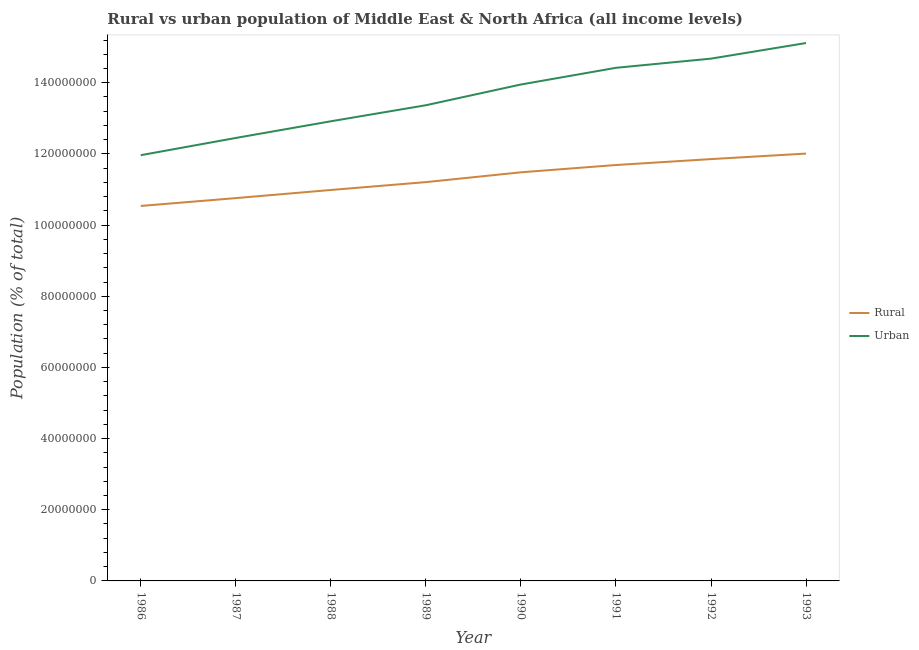Does the line corresponding to rural population density intersect with the line corresponding to urban population density?
Your answer should be compact. No. What is the rural population density in 1990?
Your answer should be compact. 1.15e+08. Across all years, what is the maximum urban population density?
Make the answer very short. 1.51e+08. Across all years, what is the minimum urban population density?
Your answer should be very brief. 1.20e+08. In which year was the urban population density maximum?
Provide a succinct answer. 1993. What is the total rural population density in the graph?
Your answer should be very brief. 9.05e+08. What is the difference between the urban population density in 1987 and that in 1988?
Ensure brevity in your answer.  -4.68e+06. What is the difference between the urban population density in 1988 and the rural population density in 1990?
Offer a very short reply. 1.43e+07. What is the average urban population density per year?
Your answer should be compact. 1.36e+08. In the year 1986, what is the difference between the urban population density and rural population density?
Your answer should be compact. 1.43e+07. What is the ratio of the urban population density in 1988 to that in 1989?
Keep it short and to the point. 0.97. What is the difference between the highest and the second highest urban population density?
Keep it short and to the point. 4.39e+06. What is the difference between the highest and the lowest urban population density?
Your answer should be compact. 3.15e+07. In how many years, is the rural population density greater than the average rural population density taken over all years?
Offer a very short reply. 4. Is the sum of the urban population density in 1991 and 1993 greater than the maximum rural population density across all years?
Your answer should be compact. Yes. Does the urban population density monotonically increase over the years?
Make the answer very short. Yes. How many lines are there?
Provide a short and direct response. 2. How many years are there in the graph?
Make the answer very short. 8. Are the values on the major ticks of Y-axis written in scientific E-notation?
Make the answer very short. No. Does the graph contain any zero values?
Keep it short and to the point. No. Does the graph contain grids?
Provide a succinct answer. No. How are the legend labels stacked?
Offer a very short reply. Vertical. What is the title of the graph?
Your answer should be very brief. Rural vs urban population of Middle East & North Africa (all income levels). What is the label or title of the Y-axis?
Your response must be concise. Population (% of total). What is the Population (% of total) of Rural in 1986?
Give a very brief answer. 1.05e+08. What is the Population (% of total) in Urban in 1986?
Your response must be concise. 1.20e+08. What is the Population (% of total) in Rural in 1987?
Ensure brevity in your answer.  1.08e+08. What is the Population (% of total) in Urban in 1987?
Make the answer very short. 1.24e+08. What is the Population (% of total) of Rural in 1988?
Offer a very short reply. 1.10e+08. What is the Population (% of total) of Urban in 1988?
Your answer should be very brief. 1.29e+08. What is the Population (% of total) of Rural in 1989?
Keep it short and to the point. 1.12e+08. What is the Population (% of total) in Urban in 1989?
Make the answer very short. 1.34e+08. What is the Population (% of total) of Rural in 1990?
Offer a very short reply. 1.15e+08. What is the Population (% of total) of Urban in 1990?
Provide a succinct answer. 1.40e+08. What is the Population (% of total) in Rural in 1991?
Keep it short and to the point. 1.17e+08. What is the Population (% of total) in Urban in 1991?
Give a very brief answer. 1.44e+08. What is the Population (% of total) of Rural in 1992?
Provide a short and direct response. 1.19e+08. What is the Population (% of total) of Urban in 1992?
Keep it short and to the point. 1.47e+08. What is the Population (% of total) of Rural in 1993?
Give a very brief answer. 1.20e+08. What is the Population (% of total) of Urban in 1993?
Your response must be concise. 1.51e+08. Across all years, what is the maximum Population (% of total) in Rural?
Provide a succinct answer. 1.20e+08. Across all years, what is the maximum Population (% of total) in Urban?
Give a very brief answer. 1.51e+08. Across all years, what is the minimum Population (% of total) of Rural?
Make the answer very short. 1.05e+08. Across all years, what is the minimum Population (% of total) in Urban?
Give a very brief answer. 1.20e+08. What is the total Population (% of total) of Rural in the graph?
Ensure brevity in your answer.  9.05e+08. What is the total Population (% of total) of Urban in the graph?
Your answer should be compact. 1.09e+09. What is the difference between the Population (% of total) in Rural in 1986 and that in 1987?
Offer a terse response. -2.20e+06. What is the difference between the Population (% of total) of Urban in 1986 and that in 1987?
Offer a very short reply. -4.84e+06. What is the difference between the Population (% of total) of Rural in 1986 and that in 1988?
Your answer should be very brief. -4.49e+06. What is the difference between the Population (% of total) of Urban in 1986 and that in 1988?
Ensure brevity in your answer.  -9.53e+06. What is the difference between the Population (% of total) in Rural in 1986 and that in 1989?
Make the answer very short. -6.70e+06. What is the difference between the Population (% of total) of Urban in 1986 and that in 1989?
Offer a terse response. -1.40e+07. What is the difference between the Population (% of total) in Rural in 1986 and that in 1990?
Your answer should be compact. -9.45e+06. What is the difference between the Population (% of total) in Urban in 1986 and that in 1990?
Offer a terse response. -1.99e+07. What is the difference between the Population (% of total) in Rural in 1986 and that in 1991?
Your answer should be compact. -1.15e+07. What is the difference between the Population (% of total) of Urban in 1986 and that in 1991?
Make the answer very short. -2.46e+07. What is the difference between the Population (% of total) in Rural in 1986 and that in 1992?
Offer a very short reply. -1.32e+07. What is the difference between the Population (% of total) of Urban in 1986 and that in 1992?
Provide a short and direct response. -2.71e+07. What is the difference between the Population (% of total) in Rural in 1986 and that in 1993?
Keep it short and to the point. -1.47e+07. What is the difference between the Population (% of total) of Urban in 1986 and that in 1993?
Provide a succinct answer. -3.15e+07. What is the difference between the Population (% of total) of Rural in 1987 and that in 1988?
Your response must be concise. -2.29e+06. What is the difference between the Population (% of total) of Urban in 1987 and that in 1988?
Ensure brevity in your answer.  -4.68e+06. What is the difference between the Population (% of total) in Rural in 1987 and that in 1989?
Your answer should be very brief. -4.50e+06. What is the difference between the Population (% of total) of Urban in 1987 and that in 1989?
Your answer should be compact. -9.20e+06. What is the difference between the Population (% of total) in Rural in 1987 and that in 1990?
Offer a very short reply. -7.25e+06. What is the difference between the Population (% of total) of Urban in 1987 and that in 1990?
Offer a terse response. -1.50e+07. What is the difference between the Population (% of total) in Rural in 1987 and that in 1991?
Make the answer very short. -9.30e+06. What is the difference between the Population (% of total) in Urban in 1987 and that in 1991?
Make the answer very short. -1.97e+07. What is the difference between the Population (% of total) in Rural in 1987 and that in 1992?
Offer a terse response. -1.10e+07. What is the difference between the Population (% of total) in Urban in 1987 and that in 1992?
Give a very brief answer. -2.23e+07. What is the difference between the Population (% of total) of Rural in 1987 and that in 1993?
Provide a short and direct response. -1.25e+07. What is the difference between the Population (% of total) of Urban in 1987 and that in 1993?
Provide a succinct answer. -2.67e+07. What is the difference between the Population (% of total) in Rural in 1988 and that in 1989?
Ensure brevity in your answer.  -2.21e+06. What is the difference between the Population (% of total) of Urban in 1988 and that in 1989?
Offer a terse response. -4.51e+06. What is the difference between the Population (% of total) in Rural in 1988 and that in 1990?
Ensure brevity in your answer.  -4.97e+06. What is the difference between the Population (% of total) of Urban in 1988 and that in 1990?
Your response must be concise. -1.03e+07. What is the difference between the Population (% of total) of Rural in 1988 and that in 1991?
Offer a terse response. -7.02e+06. What is the difference between the Population (% of total) of Urban in 1988 and that in 1991?
Make the answer very short. -1.50e+07. What is the difference between the Population (% of total) in Rural in 1988 and that in 1992?
Offer a very short reply. -8.68e+06. What is the difference between the Population (% of total) in Urban in 1988 and that in 1992?
Give a very brief answer. -1.76e+07. What is the difference between the Population (% of total) of Rural in 1988 and that in 1993?
Keep it short and to the point. -1.02e+07. What is the difference between the Population (% of total) of Urban in 1988 and that in 1993?
Keep it short and to the point. -2.20e+07. What is the difference between the Population (% of total) in Rural in 1989 and that in 1990?
Your response must be concise. -2.76e+06. What is the difference between the Population (% of total) in Urban in 1989 and that in 1990?
Provide a short and direct response. -5.83e+06. What is the difference between the Population (% of total) of Rural in 1989 and that in 1991?
Your answer should be compact. -4.81e+06. What is the difference between the Population (% of total) in Urban in 1989 and that in 1991?
Make the answer very short. -1.05e+07. What is the difference between the Population (% of total) in Rural in 1989 and that in 1992?
Offer a terse response. -6.47e+06. What is the difference between the Population (% of total) of Urban in 1989 and that in 1992?
Make the answer very short. -1.31e+07. What is the difference between the Population (% of total) in Rural in 1989 and that in 1993?
Your answer should be compact. -8.02e+06. What is the difference between the Population (% of total) of Urban in 1989 and that in 1993?
Provide a succinct answer. -1.75e+07. What is the difference between the Population (% of total) in Rural in 1990 and that in 1991?
Offer a terse response. -2.05e+06. What is the difference between the Population (% of total) in Urban in 1990 and that in 1991?
Your response must be concise. -4.69e+06. What is the difference between the Population (% of total) of Rural in 1990 and that in 1992?
Keep it short and to the point. -3.71e+06. What is the difference between the Population (% of total) of Urban in 1990 and that in 1992?
Your answer should be compact. -7.27e+06. What is the difference between the Population (% of total) in Rural in 1990 and that in 1993?
Give a very brief answer. -5.26e+06. What is the difference between the Population (% of total) of Urban in 1990 and that in 1993?
Provide a succinct answer. -1.17e+07. What is the difference between the Population (% of total) of Rural in 1991 and that in 1992?
Your answer should be compact. -1.66e+06. What is the difference between the Population (% of total) in Urban in 1991 and that in 1992?
Keep it short and to the point. -2.58e+06. What is the difference between the Population (% of total) of Rural in 1991 and that in 1993?
Provide a short and direct response. -3.21e+06. What is the difference between the Population (% of total) of Urban in 1991 and that in 1993?
Make the answer very short. -6.97e+06. What is the difference between the Population (% of total) in Rural in 1992 and that in 1993?
Make the answer very short. -1.55e+06. What is the difference between the Population (% of total) in Urban in 1992 and that in 1993?
Offer a terse response. -4.39e+06. What is the difference between the Population (% of total) of Rural in 1986 and the Population (% of total) of Urban in 1987?
Your answer should be compact. -1.91e+07. What is the difference between the Population (% of total) in Rural in 1986 and the Population (% of total) in Urban in 1988?
Give a very brief answer. -2.38e+07. What is the difference between the Population (% of total) in Rural in 1986 and the Population (% of total) in Urban in 1989?
Your answer should be very brief. -2.83e+07. What is the difference between the Population (% of total) in Rural in 1986 and the Population (% of total) in Urban in 1990?
Offer a very short reply. -3.41e+07. What is the difference between the Population (% of total) in Rural in 1986 and the Population (% of total) in Urban in 1991?
Provide a short and direct response. -3.88e+07. What is the difference between the Population (% of total) in Rural in 1986 and the Population (% of total) in Urban in 1992?
Offer a terse response. -4.14e+07. What is the difference between the Population (% of total) in Rural in 1986 and the Population (% of total) in Urban in 1993?
Offer a terse response. -4.58e+07. What is the difference between the Population (% of total) of Rural in 1987 and the Population (% of total) of Urban in 1988?
Give a very brief answer. -2.16e+07. What is the difference between the Population (% of total) of Rural in 1987 and the Population (% of total) of Urban in 1989?
Keep it short and to the point. -2.61e+07. What is the difference between the Population (% of total) in Rural in 1987 and the Population (% of total) in Urban in 1990?
Keep it short and to the point. -3.19e+07. What is the difference between the Population (% of total) in Rural in 1987 and the Population (% of total) in Urban in 1991?
Give a very brief answer. -3.66e+07. What is the difference between the Population (% of total) of Rural in 1987 and the Population (% of total) of Urban in 1992?
Give a very brief answer. -3.92e+07. What is the difference between the Population (% of total) of Rural in 1987 and the Population (% of total) of Urban in 1993?
Offer a terse response. -4.36e+07. What is the difference between the Population (% of total) of Rural in 1988 and the Population (% of total) of Urban in 1989?
Your response must be concise. -2.38e+07. What is the difference between the Population (% of total) in Rural in 1988 and the Population (% of total) in Urban in 1990?
Ensure brevity in your answer.  -2.96e+07. What is the difference between the Population (% of total) in Rural in 1988 and the Population (% of total) in Urban in 1991?
Offer a very short reply. -3.43e+07. What is the difference between the Population (% of total) in Rural in 1988 and the Population (% of total) in Urban in 1992?
Provide a short and direct response. -3.69e+07. What is the difference between the Population (% of total) in Rural in 1988 and the Population (% of total) in Urban in 1993?
Offer a very short reply. -4.13e+07. What is the difference between the Population (% of total) of Rural in 1989 and the Population (% of total) of Urban in 1990?
Keep it short and to the point. -2.74e+07. What is the difference between the Population (% of total) of Rural in 1989 and the Population (% of total) of Urban in 1991?
Your response must be concise. -3.21e+07. What is the difference between the Population (% of total) of Rural in 1989 and the Population (% of total) of Urban in 1992?
Offer a very short reply. -3.47e+07. What is the difference between the Population (% of total) of Rural in 1989 and the Population (% of total) of Urban in 1993?
Ensure brevity in your answer.  -3.91e+07. What is the difference between the Population (% of total) in Rural in 1990 and the Population (% of total) in Urban in 1991?
Provide a succinct answer. -2.94e+07. What is the difference between the Population (% of total) of Rural in 1990 and the Population (% of total) of Urban in 1992?
Your answer should be compact. -3.19e+07. What is the difference between the Population (% of total) in Rural in 1990 and the Population (% of total) in Urban in 1993?
Give a very brief answer. -3.63e+07. What is the difference between the Population (% of total) in Rural in 1991 and the Population (% of total) in Urban in 1992?
Your answer should be compact. -2.99e+07. What is the difference between the Population (% of total) in Rural in 1991 and the Population (% of total) in Urban in 1993?
Your answer should be very brief. -3.43e+07. What is the difference between the Population (% of total) in Rural in 1992 and the Population (% of total) in Urban in 1993?
Give a very brief answer. -3.26e+07. What is the average Population (% of total) in Rural per year?
Your answer should be compact. 1.13e+08. What is the average Population (% of total) in Urban per year?
Ensure brevity in your answer.  1.36e+08. In the year 1986, what is the difference between the Population (% of total) in Rural and Population (% of total) in Urban?
Keep it short and to the point. -1.43e+07. In the year 1987, what is the difference between the Population (% of total) of Rural and Population (% of total) of Urban?
Make the answer very short. -1.69e+07. In the year 1988, what is the difference between the Population (% of total) of Rural and Population (% of total) of Urban?
Your answer should be compact. -1.93e+07. In the year 1989, what is the difference between the Population (% of total) of Rural and Population (% of total) of Urban?
Make the answer very short. -2.16e+07. In the year 1990, what is the difference between the Population (% of total) of Rural and Population (% of total) of Urban?
Give a very brief answer. -2.47e+07. In the year 1991, what is the difference between the Population (% of total) of Rural and Population (% of total) of Urban?
Your answer should be compact. -2.73e+07. In the year 1992, what is the difference between the Population (% of total) in Rural and Population (% of total) in Urban?
Make the answer very short. -2.82e+07. In the year 1993, what is the difference between the Population (% of total) in Rural and Population (% of total) in Urban?
Ensure brevity in your answer.  -3.11e+07. What is the ratio of the Population (% of total) of Rural in 1986 to that in 1987?
Keep it short and to the point. 0.98. What is the ratio of the Population (% of total) in Urban in 1986 to that in 1987?
Your response must be concise. 0.96. What is the ratio of the Population (% of total) of Rural in 1986 to that in 1988?
Your answer should be very brief. 0.96. What is the ratio of the Population (% of total) in Urban in 1986 to that in 1988?
Ensure brevity in your answer.  0.93. What is the ratio of the Population (% of total) of Rural in 1986 to that in 1989?
Ensure brevity in your answer.  0.94. What is the ratio of the Population (% of total) of Urban in 1986 to that in 1989?
Your answer should be very brief. 0.9. What is the ratio of the Population (% of total) in Rural in 1986 to that in 1990?
Your answer should be very brief. 0.92. What is the ratio of the Population (% of total) of Urban in 1986 to that in 1990?
Offer a terse response. 0.86. What is the ratio of the Population (% of total) in Rural in 1986 to that in 1991?
Offer a very short reply. 0.9. What is the ratio of the Population (% of total) of Urban in 1986 to that in 1991?
Keep it short and to the point. 0.83. What is the ratio of the Population (% of total) of Rural in 1986 to that in 1992?
Ensure brevity in your answer.  0.89. What is the ratio of the Population (% of total) of Urban in 1986 to that in 1992?
Offer a very short reply. 0.82. What is the ratio of the Population (% of total) in Rural in 1986 to that in 1993?
Make the answer very short. 0.88. What is the ratio of the Population (% of total) of Urban in 1986 to that in 1993?
Ensure brevity in your answer.  0.79. What is the ratio of the Population (% of total) in Rural in 1987 to that in 1988?
Ensure brevity in your answer.  0.98. What is the ratio of the Population (% of total) in Urban in 1987 to that in 1988?
Your response must be concise. 0.96. What is the ratio of the Population (% of total) of Rural in 1987 to that in 1989?
Give a very brief answer. 0.96. What is the ratio of the Population (% of total) of Urban in 1987 to that in 1989?
Ensure brevity in your answer.  0.93. What is the ratio of the Population (% of total) of Rural in 1987 to that in 1990?
Keep it short and to the point. 0.94. What is the ratio of the Population (% of total) of Urban in 1987 to that in 1990?
Give a very brief answer. 0.89. What is the ratio of the Population (% of total) in Rural in 1987 to that in 1991?
Your response must be concise. 0.92. What is the ratio of the Population (% of total) in Urban in 1987 to that in 1991?
Give a very brief answer. 0.86. What is the ratio of the Population (% of total) of Rural in 1987 to that in 1992?
Your answer should be very brief. 0.91. What is the ratio of the Population (% of total) in Urban in 1987 to that in 1992?
Provide a succinct answer. 0.85. What is the ratio of the Population (% of total) of Rural in 1987 to that in 1993?
Give a very brief answer. 0.9. What is the ratio of the Population (% of total) of Urban in 1987 to that in 1993?
Your answer should be very brief. 0.82. What is the ratio of the Population (% of total) in Rural in 1988 to that in 1989?
Offer a very short reply. 0.98. What is the ratio of the Population (% of total) of Urban in 1988 to that in 1989?
Provide a short and direct response. 0.97. What is the ratio of the Population (% of total) in Rural in 1988 to that in 1990?
Give a very brief answer. 0.96. What is the ratio of the Population (% of total) in Urban in 1988 to that in 1990?
Offer a terse response. 0.93. What is the ratio of the Population (% of total) in Urban in 1988 to that in 1991?
Provide a succinct answer. 0.9. What is the ratio of the Population (% of total) in Rural in 1988 to that in 1992?
Give a very brief answer. 0.93. What is the ratio of the Population (% of total) in Rural in 1988 to that in 1993?
Your answer should be compact. 0.91. What is the ratio of the Population (% of total) of Urban in 1988 to that in 1993?
Provide a succinct answer. 0.85. What is the ratio of the Population (% of total) of Rural in 1989 to that in 1990?
Give a very brief answer. 0.98. What is the ratio of the Population (% of total) of Urban in 1989 to that in 1990?
Keep it short and to the point. 0.96. What is the ratio of the Population (% of total) of Rural in 1989 to that in 1991?
Keep it short and to the point. 0.96. What is the ratio of the Population (% of total) of Urban in 1989 to that in 1991?
Your answer should be very brief. 0.93. What is the ratio of the Population (% of total) in Rural in 1989 to that in 1992?
Your answer should be compact. 0.95. What is the ratio of the Population (% of total) of Urban in 1989 to that in 1992?
Give a very brief answer. 0.91. What is the ratio of the Population (% of total) in Rural in 1989 to that in 1993?
Make the answer very short. 0.93. What is the ratio of the Population (% of total) in Urban in 1989 to that in 1993?
Ensure brevity in your answer.  0.88. What is the ratio of the Population (% of total) in Rural in 1990 to that in 1991?
Keep it short and to the point. 0.98. What is the ratio of the Population (% of total) in Urban in 1990 to that in 1991?
Make the answer very short. 0.97. What is the ratio of the Population (% of total) in Rural in 1990 to that in 1992?
Make the answer very short. 0.97. What is the ratio of the Population (% of total) of Urban in 1990 to that in 1992?
Provide a short and direct response. 0.95. What is the ratio of the Population (% of total) in Rural in 1990 to that in 1993?
Your answer should be very brief. 0.96. What is the ratio of the Population (% of total) in Urban in 1990 to that in 1993?
Keep it short and to the point. 0.92. What is the ratio of the Population (% of total) in Urban in 1991 to that in 1992?
Ensure brevity in your answer.  0.98. What is the ratio of the Population (% of total) in Rural in 1991 to that in 1993?
Ensure brevity in your answer.  0.97. What is the ratio of the Population (% of total) in Urban in 1991 to that in 1993?
Provide a succinct answer. 0.95. What is the ratio of the Population (% of total) in Rural in 1992 to that in 1993?
Your answer should be very brief. 0.99. What is the difference between the highest and the second highest Population (% of total) in Rural?
Make the answer very short. 1.55e+06. What is the difference between the highest and the second highest Population (% of total) of Urban?
Your answer should be very brief. 4.39e+06. What is the difference between the highest and the lowest Population (% of total) of Rural?
Your answer should be compact. 1.47e+07. What is the difference between the highest and the lowest Population (% of total) in Urban?
Keep it short and to the point. 3.15e+07. 